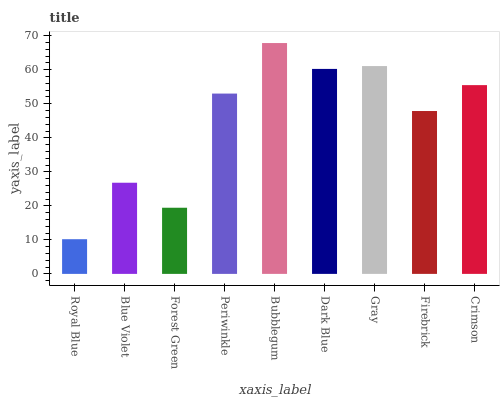Is Royal Blue the minimum?
Answer yes or no. Yes. Is Bubblegum the maximum?
Answer yes or no. Yes. Is Blue Violet the minimum?
Answer yes or no. No. Is Blue Violet the maximum?
Answer yes or no. No. Is Blue Violet greater than Royal Blue?
Answer yes or no. Yes. Is Royal Blue less than Blue Violet?
Answer yes or no. Yes. Is Royal Blue greater than Blue Violet?
Answer yes or no. No. Is Blue Violet less than Royal Blue?
Answer yes or no. No. Is Periwinkle the high median?
Answer yes or no. Yes. Is Periwinkle the low median?
Answer yes or no. Yes. Is Royal Blue the high median?
Answer yes or no. No. Is Dark Blue the low median?
Answer yes or no. No. 